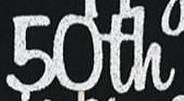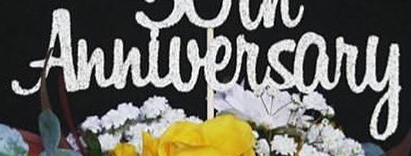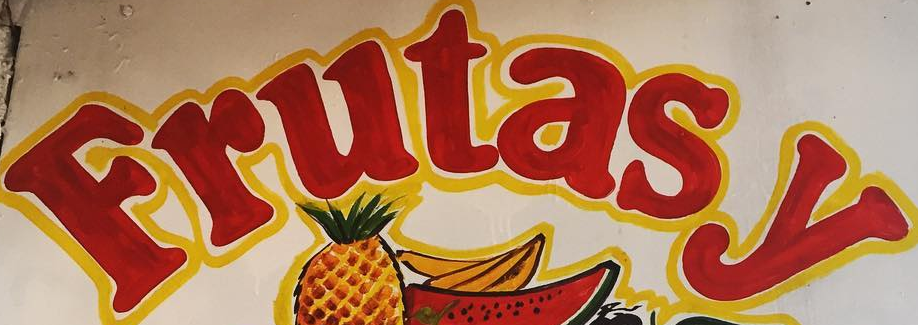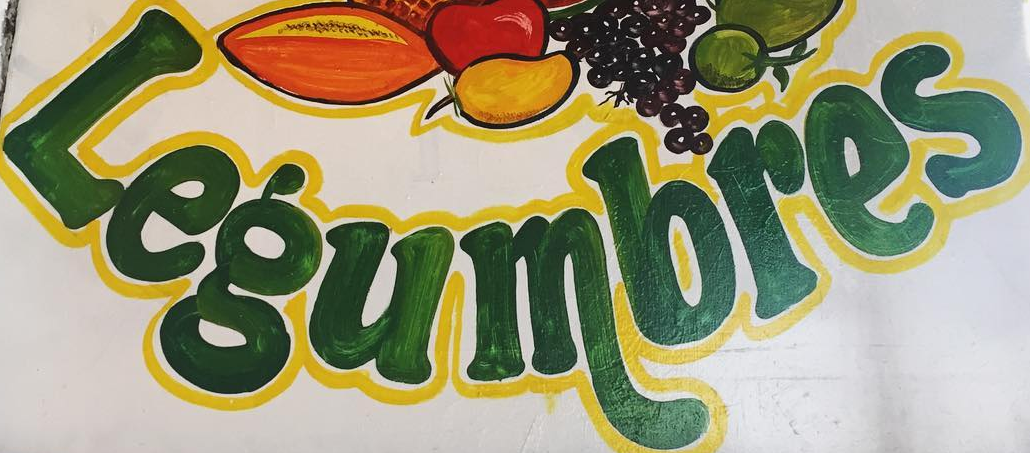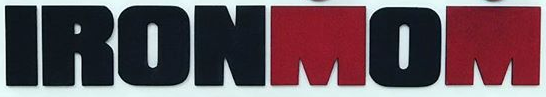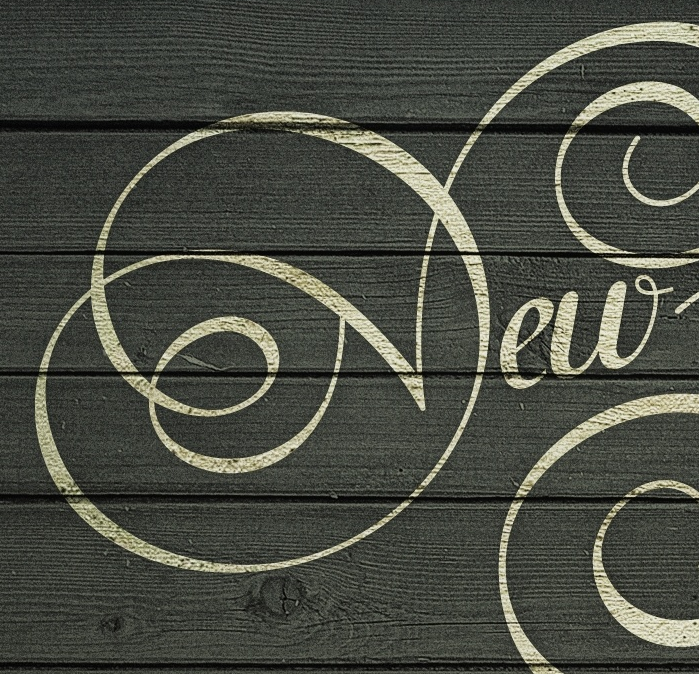Identify the words shown in these images in order, separated by a semicolon. 50th; Anniversary; Frutasy; Legumbres; IRONMOM; New 